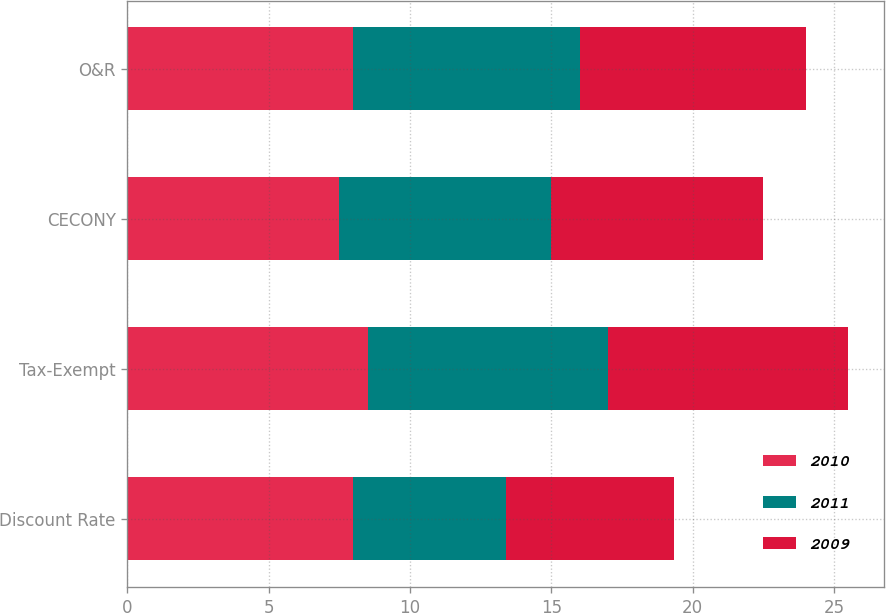Convert chart to OTSL. <chart><loc_0><loc_0><loc_500><loc_500><stacked_bar_chart><ecel><fcel>Discount Rate<fcel>Tax-Exempt<fcel>CECONY<fcel>O&R<nl><fcel>2010<fcel>8<fcel>8.5<fcel>7.5<fcel>8<nl><fcel>2011<fcel>5.4<fcel>8.5<fcel>7.5<fcel>8<nl><fcel>2009<fcel>5.95<fcel>8.5<fcel>7.5<fcel>8<nl></chart> 